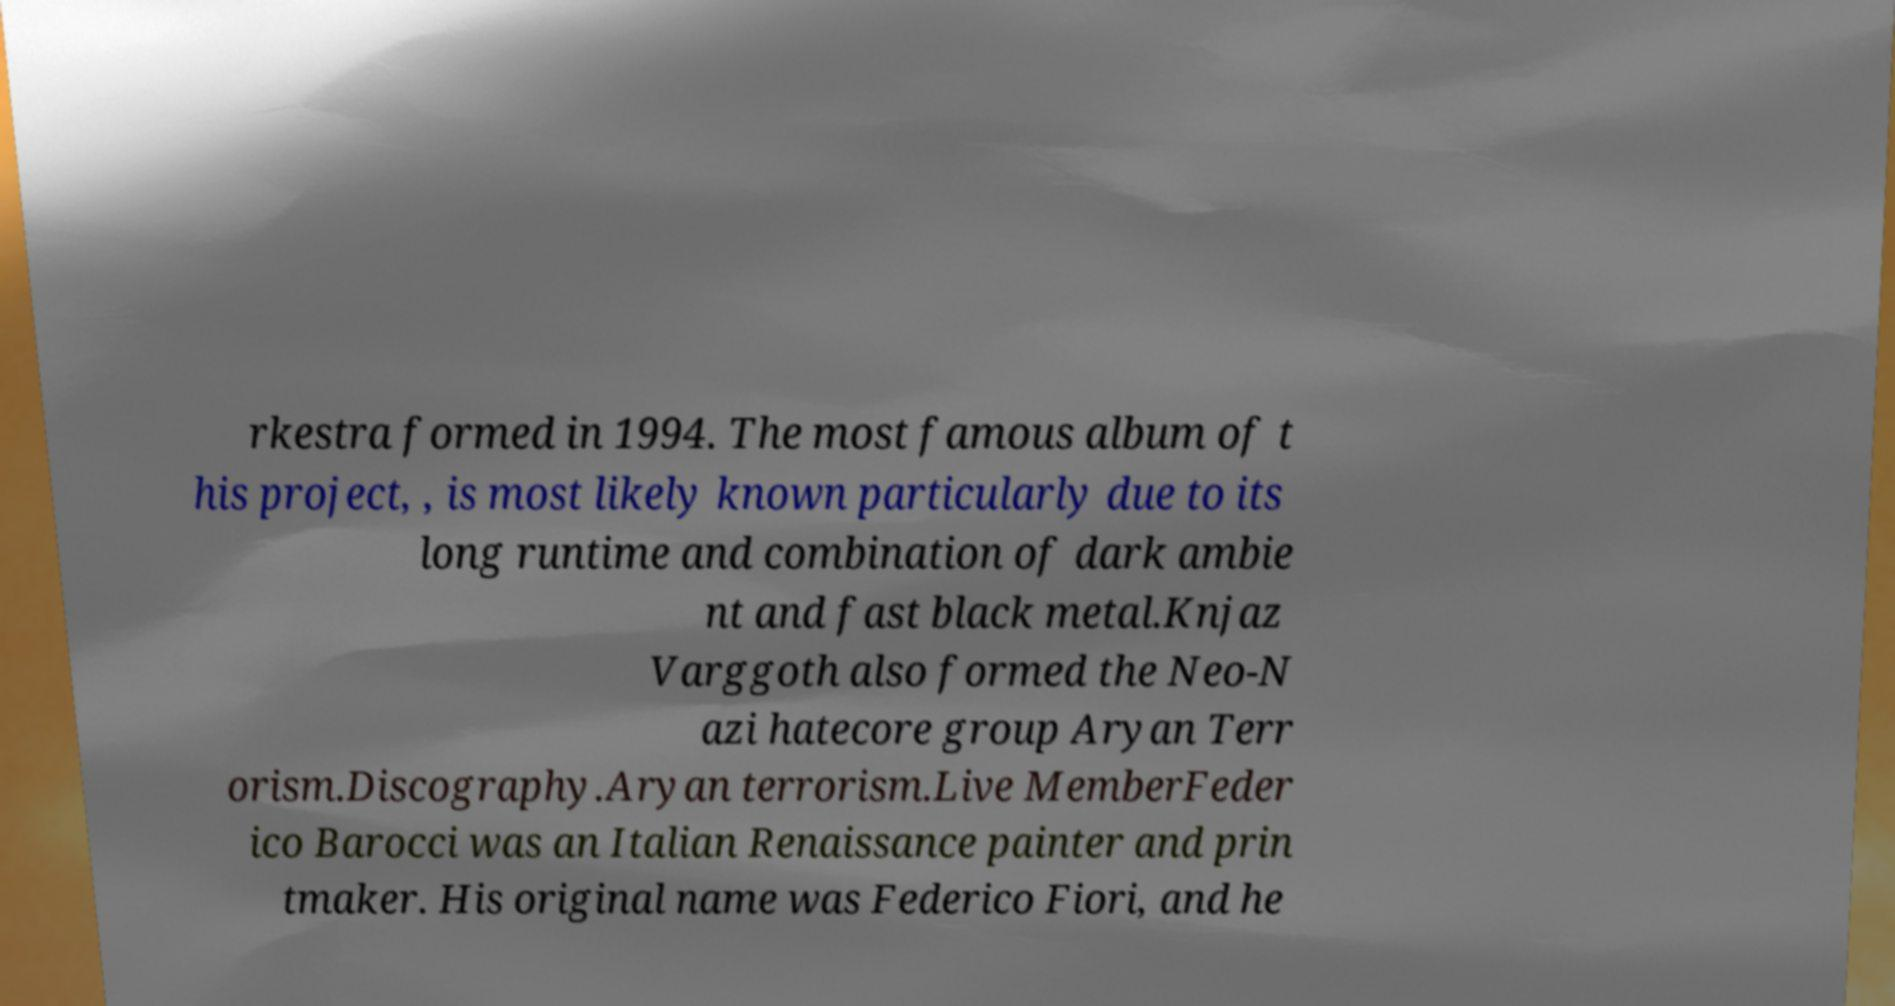Can you read and provide the text displayed in the image?This photo seems to have some interesting text. Can you extract and type it out for me? rkestra formed in 1994. The most famous album of t his project, , is most likely known particularly due to its long runtime and combination of dark ambie nt and fast black metal.Knjaz Varggoth also formed the Neo-N azi hatecore group Aryan Terr orism.Discography.Aryan terrorism.Live MemberFeder ico Barocci was an Italian Renaissance painter and prin tmaker. His original name was Federico Fiori, and he 